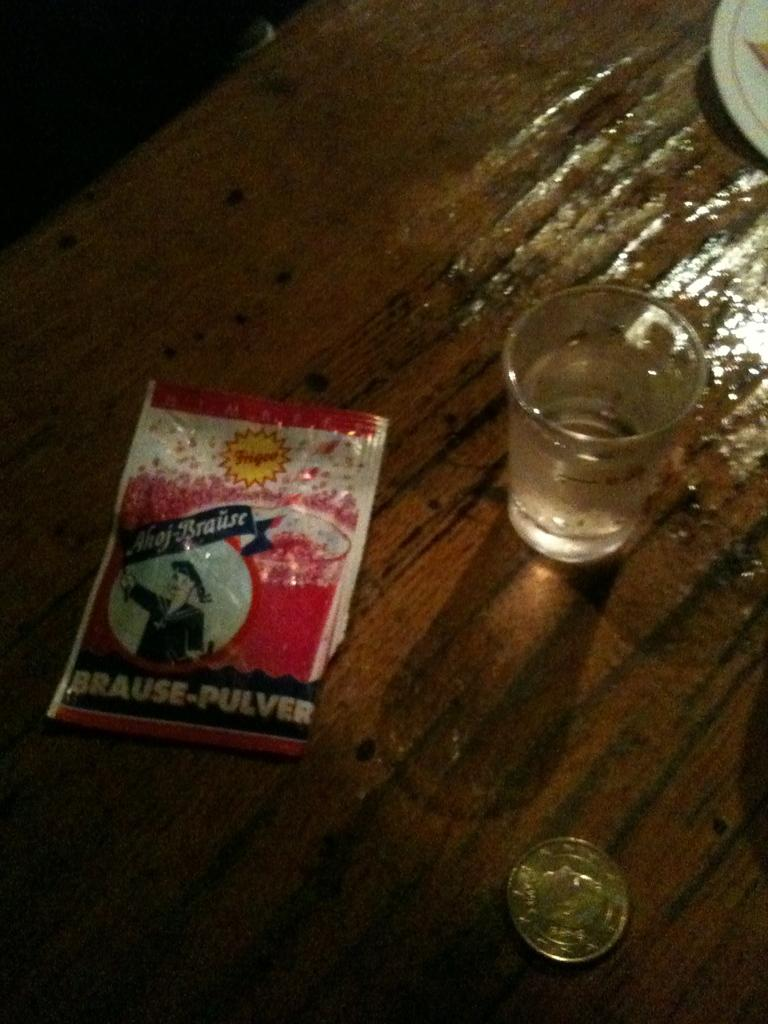What type of container is visible in the image? There is a glass in the image. What other object can be seen on the table? There is a plate in the image. Is there any object that covers or protects something in the image? Yes, there is a cover in the image. What small object is present on the table? There is a coin in the image. What type of harmony is being played in the background of the image? There is no music or harmony present in the image; it only features a glass, plate, cover, and coin on a table. What class of people is depicted in the image? There are no people depicted in the image, only objects. 